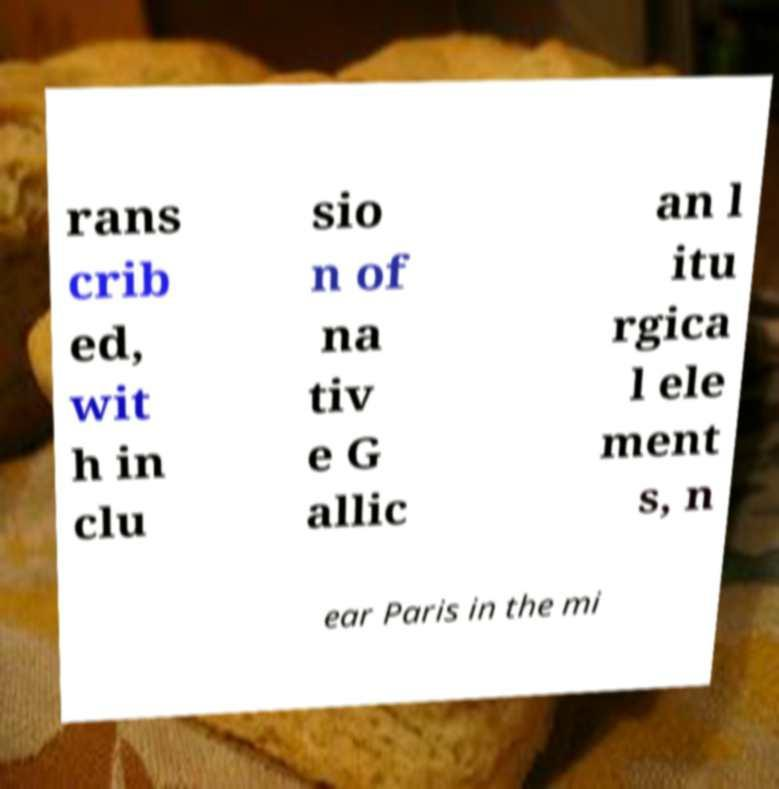Can you read and provide the text displayed in the image?This photo seems to have some interesting text. Can you extract and type it out for me? rans crib ed, wit h in clu sio n of na tiv e G allic an l itu rgica l ele ment s, n ear Paris in the mi 